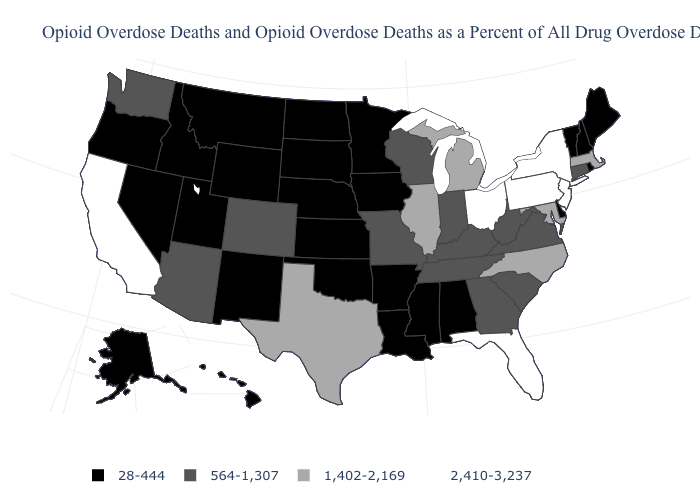Which states hav the highest value in the MidWest?
Give a very brief answer. Ohio. What is the value of Indiana?
Write a very short answer. 564-1,307. Name the states that have a value in the range 2,410-3,237?
Short answer required. California, Florida, New Jersey, New York, Ohio, Pennsylvania. Does Wyoming have a lower value than New York?
Be succinct. Yes. How many symbols are there in the legend?
Be succinct. 4. Name the states that have a value in the range 2,410-3,237?
Concise answer only. California, Florida, New Jersey, New York, Ohio, Pennsylvania. What is the value of Vermont?
Be succinct. 28-444. How many symbols are there in the legend?
Write a very short answer. 4. Does Massachusetts have the lowest value in the USA?
Keep it brief. No. Name the states that have a value in the range 564-1,307?
Write a very short answer. Arizona, Colorado, Connecticut, Georgia, Indiana, Kentucky, Missouri, South Carolina, Tennessee, Virginia, Washington, West Virginia, Wisconsin. What is the value of North Dakota?
Be succinct. 28-444. What is the value of North Carolina?
Concise answer only. 1,402-2,169. What is the highest value in states that border Nevada?
Give a very brief answer. 2,410-3,237. Does the first symbol in the legend represent the smallest category?
Be succinct. Yes. Does Michigan have a lower value than Kansas?
Short answer required. No. 